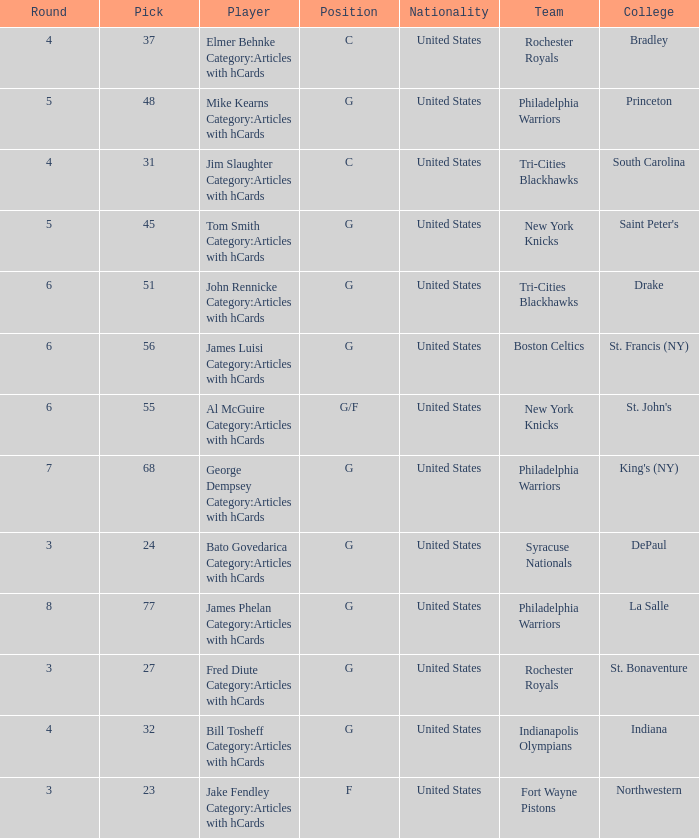What is the smallest draft number for players from king's (ny)? 68.0. 